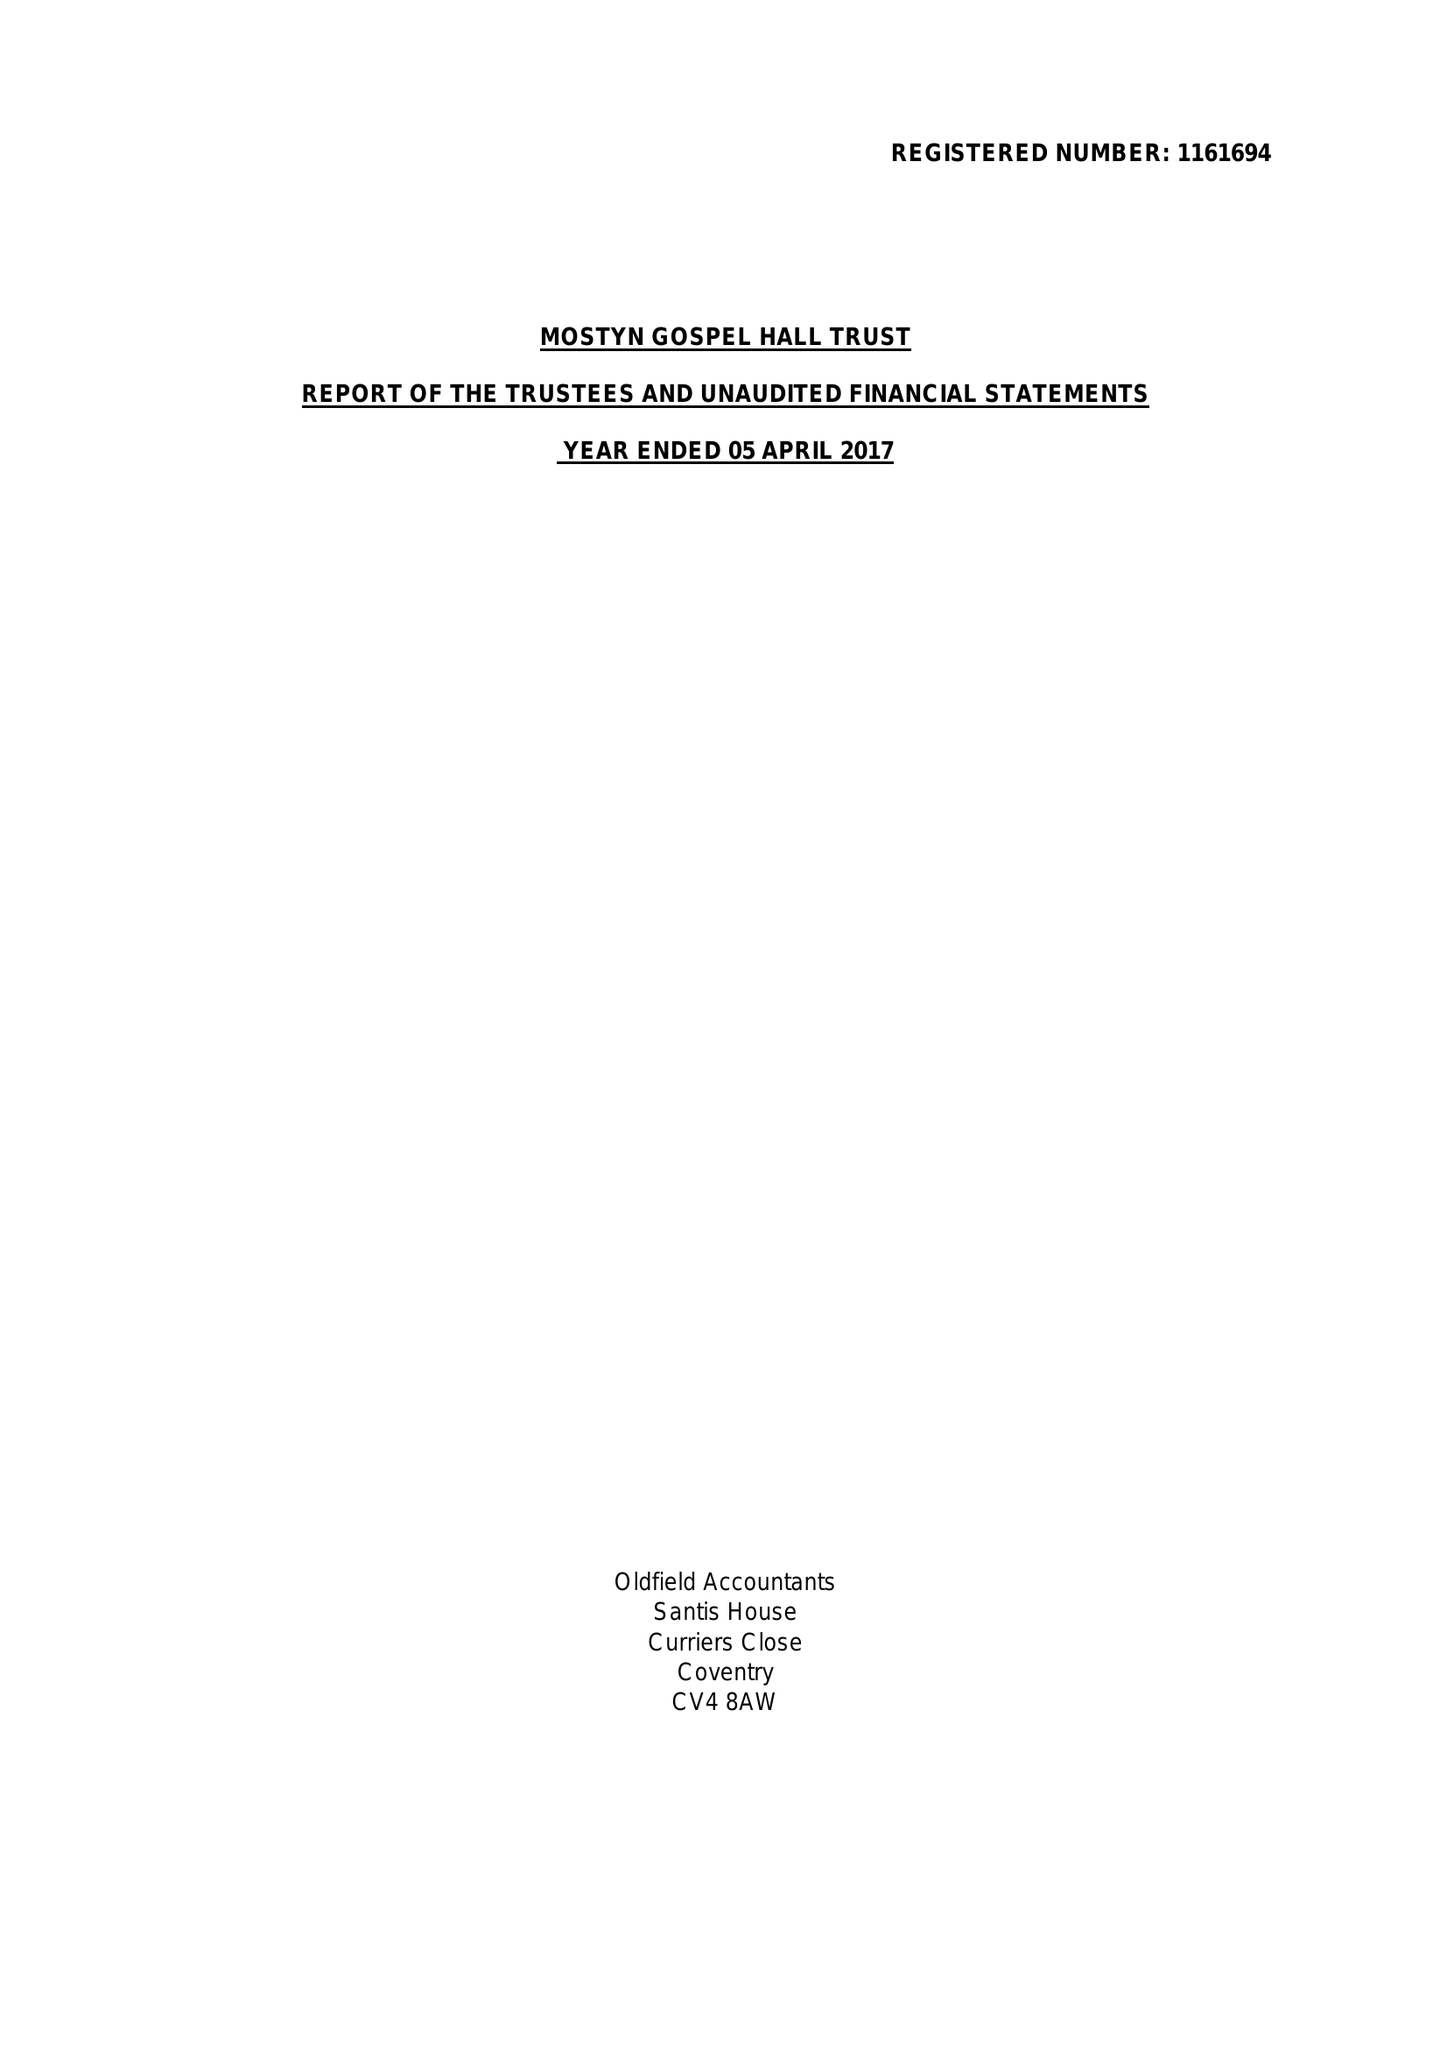What is the value for the report_date?
Answer the question using a single word or phrase. 2017-04-05 